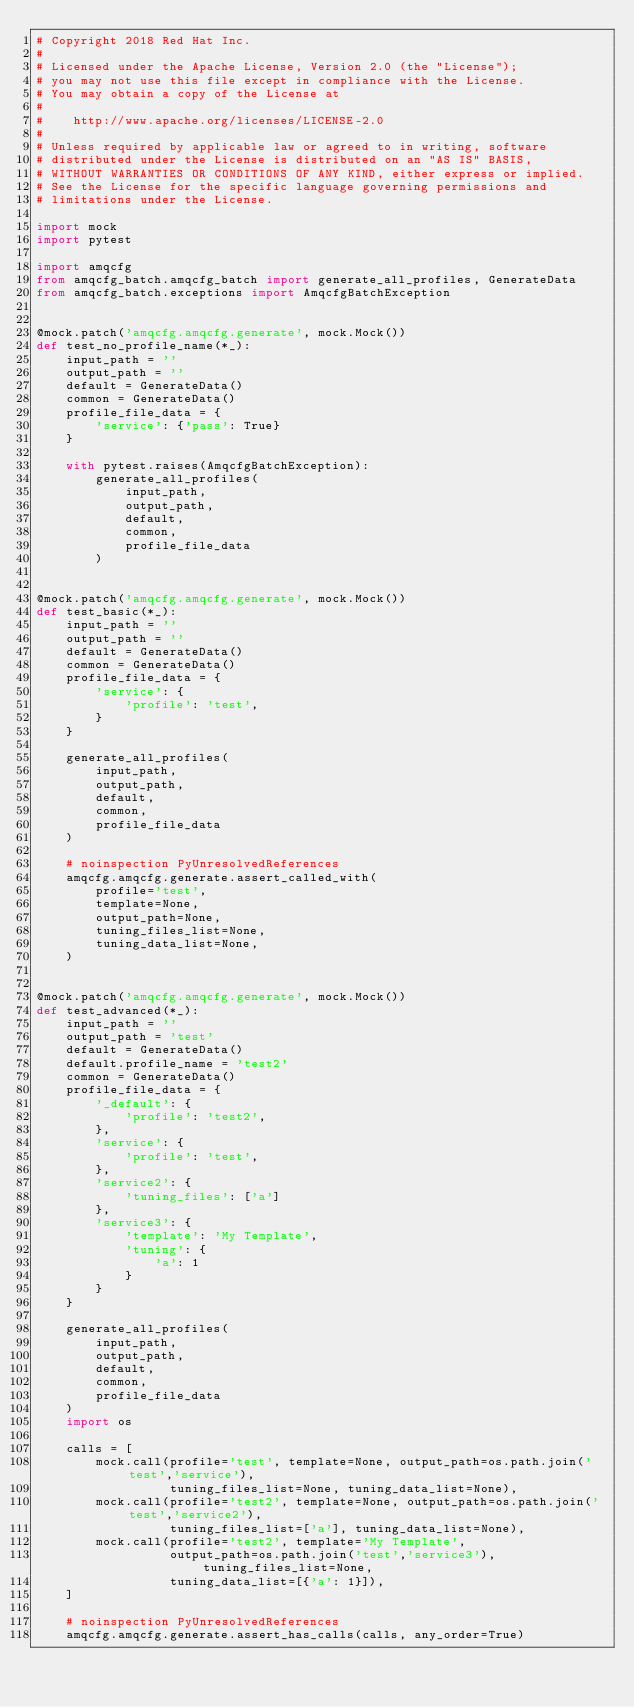<code> <loc_0><loc_0><loc_500><loc_500><_Python_># Copyright 2018 Red Hat Inc.
#
# Licensed under the Apache License, Version 2.0 (the "License");
# you may not use this file except in compliance with the License.
# You may obtain a copy of the License at
#
#    http://www.apache.org/licenses/LICENSE-2.0
#
# Unless required by applicable law or agreed to in writing, software
# distributed under the License is distributed on an "AS IS" BASIS,
# WITHOUT WARRANTIES OR CONDITIONS OF ANY KIND, either express or implied.
# See the License for the specific language governing permissions and
# limitations under the License.

import mock
import pytest

import amqcfg
from amqcfg_batch.amqcfg_batch import generate_all_profiles, GenerateData
from amqcfg_batch.exceptions import AmqcfgBatchException


@mock.patch('amqcfg.amqcfg.generate', mock.Mock())
def test_no_profile_name(*_):
    input_path = ''
    output_path = ''
    default = GenerateData()
    common = GenerateData()
    profile_file_data = {
        'service': {'pass': True}
    }

    with pytest.raises(AmqcfgBatchException):
        generate_all_profiles(
            input_path,
            output_path,
            default,
            common,
            profile_file_data
        )


@mock.patch('amqcfg.amqcfg.generate', mock.Mock())
def test_basic(*_):
    input_path = ''
    output_path = ''
    default = GenerateData()
    common = GenerateData()
    profile_file_data = {
        'service': {
            'profile': 'test',
        }
    }

    generate_all_profiles(
        input_path,
        output_path,
        default,
        common,
        profile_file_data
    )

    # noinspection PyUnresolvedReferences
    amqcfg.amqcfg.generate.assert_called_with(
        profile='test',
        template=None,
        output_path=None,
        tuning_files_list=None,
        tuning_data_list=None,
    )


@mock.patch('amqcfg.amqcfg.generate', mock.Mock())
def test_advanced(*_):
    input_path = ''
    output_path = 'test'
    default = GenerateData()
    default.profile_name = 'test2'
    common = GenerateData()
    profile_file_data = {
        '_default': {
            'profile': 'test2',
        },
        'service': {
            'profile': 'test',
        },
        'service2': {
            'tuning_files': ['a']
        },
        'service3': {
            'template': 'My Template',
            'tuning': {
                'a': 1
            }
        }
    }

    generate_all_profiles(
        input_path,
        output_path,
        default,
        common,
        profile_file_data
    )
    import os

    calls = [
        mock.call(profile='test', template=None, output_path=os.path.join('test','service'),
                  tuning_files_list=None, tuning_data_list=None),
        mock.call(profile='test2', template=None, output_path=os.path.join('test','service2'),
                  tuning_files_list=['a'], tuning_data_list=None),
        mock.call(profile='test2', template='My Template',
                  output_path=os.path.join('test','service3'), tuning_files_list=None,
                  tuning_data_list=[{'a': 1}]),
    ]

    # noinspection PyUnresolvedReferences
    amqcfg.amqcfg.generate.assert_has_calls(calls, any_order=True)
</code> 